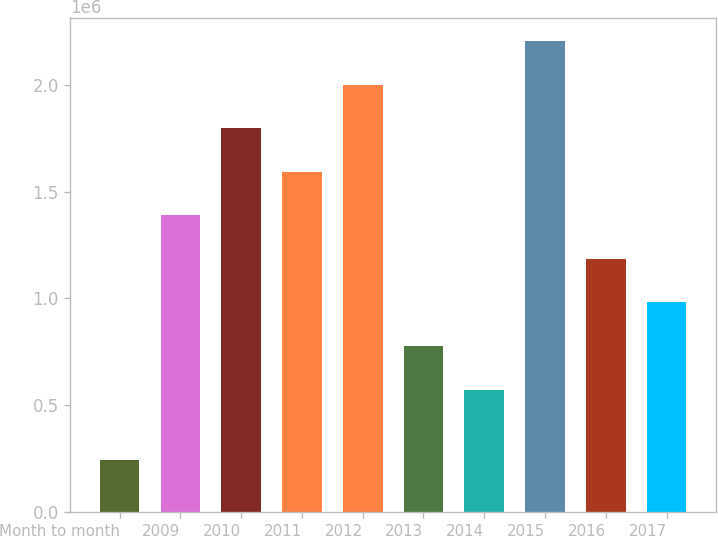Convert chart. <chart><loc_0><loc_0><loc_500><loc_500><bar_chart><fcel>Month to month<fcel>2009<fcel>2010<fcel>2011<fcel>2012<fcel>2013<fcel>2014<fcel>2015<fcel>2016<fcel>2017<nl><fcel>242000<fcel>1.389e+06<fcel>1.797e+06<fcel>1.593e+06<fcel>2.001e+06<fcel>777000<fcel>573000<fcel>2.205e+06<fcel>1.185e+06<fcel>981000<nl></chart> 